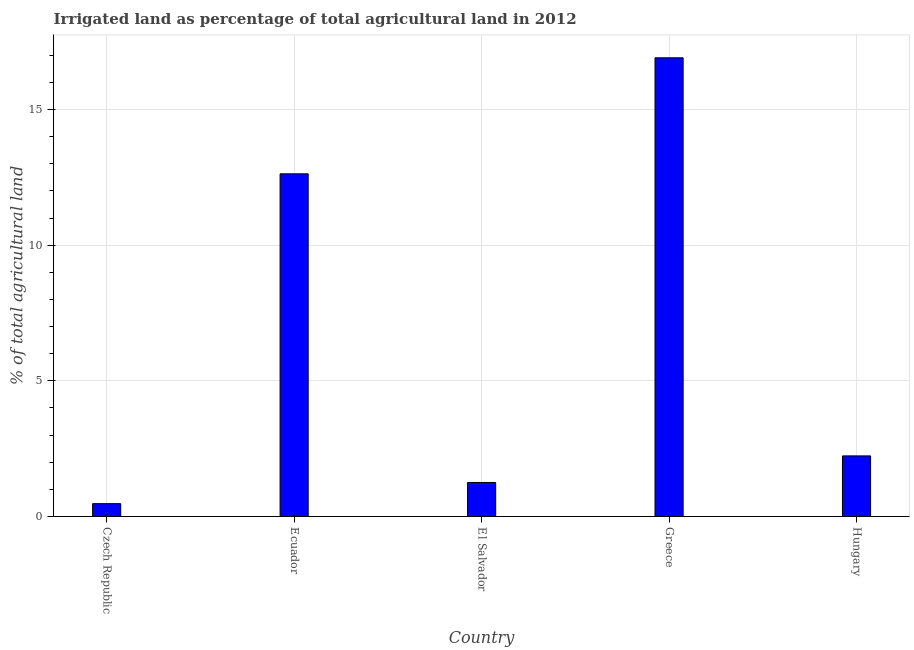Does the graph contain any zero values?
Give a very brief answer. No. What is the title of the graph?
Give a very brief answer. Irrigated land as percentage of total agricultural land in 2012. What is the label or title of the Y-axis?
Make the answer very short. % of total agricultural land. What is the percentage of agricultural irrigated land in Ecuador?
Offer a terse response. 12.63. Across all countries, what is the maximum percentage of agricultural irrigated land?
Your response must be concise. 16.9. Across all countries, what is the minimum percentage of agricultural irrigated land?
Provide a succinct answer. 0.47. In which country was the percentage of agricultural irrigated land minimum?
Your response must be concise. Czech Republic. What is the sum of the percentage of agricultural irrigated land?
Keep it short and to the point. 33.49. What is the difference between the percentage of agricultural irrigated land in Ecuador and El Salvador?
Offer a terse response. 11.38. What is the average percentage of agricultural irrigated land per country?
Your response must be concise. 6.7. What is the median percentage of agricultural irrigated land?
Offer a terse response. 2.23. What is the ratio of the percentage of agricultural irrigated land in Czech Republic to that in Greece?
Your answer should be very brief. 0.03. What is the difference between the highest and the second highest percentage of agricultural irrigated land?
Ensure brevity in your answer.  4.28. What is the difference between the highest and the lowest percentage of agricultural irrigated land?
Provide a succinct answer. 16.43. How many countries are there in the graph?
Offer a terse response. 5. What is the difference between two consecutive major ticks on the Y-axis?
Provide a short and direct response. 5. Are the values on the major ticks of Y-axis written in scientific E-notation?
Keep it short and to the point. No. What is the % of total agricultural land of Czech Republic?
Provide a short and direct response. 0.47. What is the % of total agricultural land in Ecuador?
Keep it short and to the point. 12.63. What is the % of total agricultural land of El Salvador?
Provide a short and direct response. 1.25. What is the % of total agricultural land of Greece?
Your answer should be very brief. 16.9. What is the % of total agricultural land of Hungary?
Your answer should be compact. 2.23. What is the difference between the % of total agricultural land in Czech Republic and Ecuador?
Give a very brief answer. -12.16. What is the difference between the % of total agricultural land in Czech Republic and El Salvador?
Ensure brevity in your answer.  -0.78. What is the difference between the % of total agricultural land in Czech Republic and Greece?
Keep it short and to the point. -16.43. What is the difference between the % of total agricultural land in Czech Republic and Hungary?
Your response must be concise. -1.76. What is the difference between the % of total agricultural land in Ecuador and El Salvador?
Your response must be concise. 11.38. What is the difference between the % of total agricultural land in Ecuador and Greece?
Give a very brief answer. -4.28. What is the difference between the % of total agricultural land in Ecuador and Hungary?
Your response must be concise. 10.4. What is the difference between the % of total agricultural land in El Salvador and Greece?
Make the answer very short. -15.65. What is the difference between the % of total agricultural land in El Salvador and Hungary?
Your answer should be compact. -0.98. What is the difference between the % of total agricultural land in Greece and Hungary?
Ensure brevity in your answer.  14.67. What is the ratio of the % of total agricultural land in Czech Republic to that in Ecuador?
Provide a short and direct response. 0.04. What is the ratio of the % of total agricultural land in Czech Republic to that in El Salvador?
Give a very brief answer. 0.38. What is the ratio of the % of total agricultural land in Czech Republic to that in Greece?
Offer a very short reply. 0.03. What is the ratio of the % of total agricultural land in Czech Republic to that in Hungary?
Give a very brief answer. 0.21. What is the ratio of the % of total agricultural land in Ecuador to that in El Salvador?
Your response must be concise. 10.08. What is the ratio of the % of total agricultural land in Ecuador to that in Greece?
Keep it short and to the point. 0.75. What is the ratio of the % of total agricultural land in Ecuador to that in Hungary?
Offer a terse response. 5.66. What is the ratio of the % of total agricultural land in El Salvador to that in Greece?
Your answer should be compact. 0.07. What is the ratio of the % of total agricultural land in El Salvador to that in Hungary?
Offer a very short reply. 0.56. What is the ratio of the % of total agricultural land in Greece to that in Hungary?
Provide a short and direct response. 7.57. 